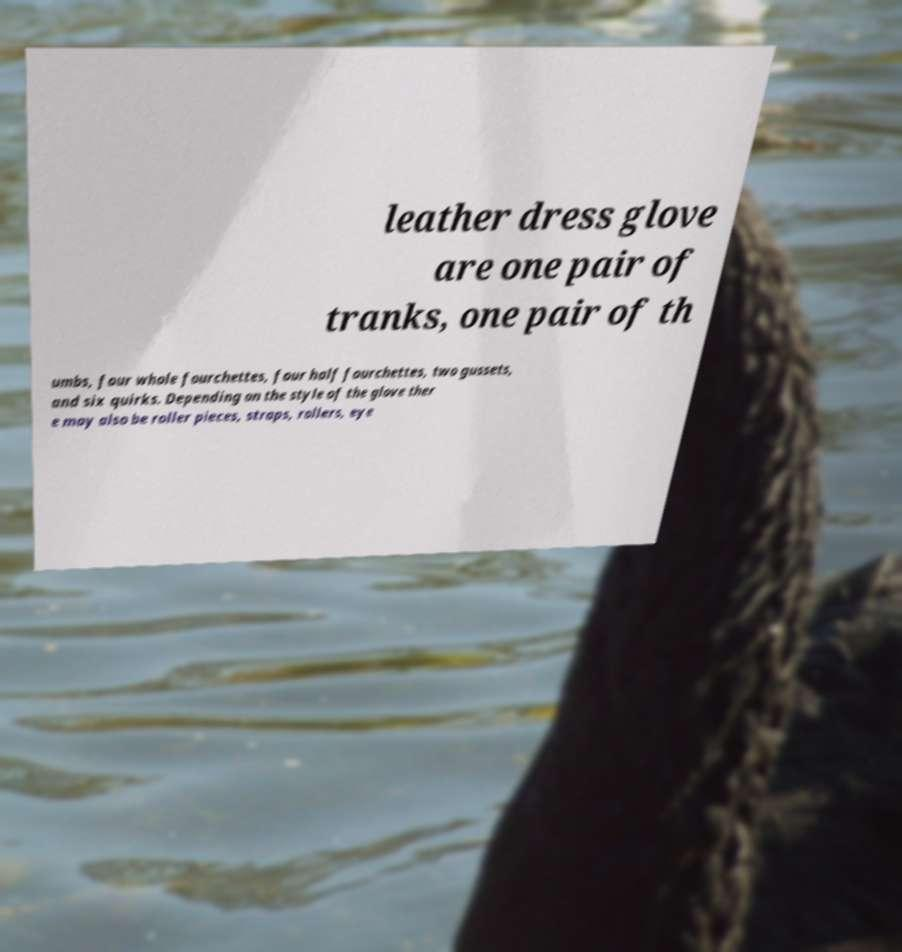Can you read and provide the text displayed in the image?This photo seems to have some interesting text. Can you extract and type it out for me? leather dress glove are one pair of tranks, one pair of th umbs, four whole fourchettes, four half fourchettes, two gussets, and six quirks. Depending on the style of the glove ther e may also be roller pieces, straps, rollers, eye 